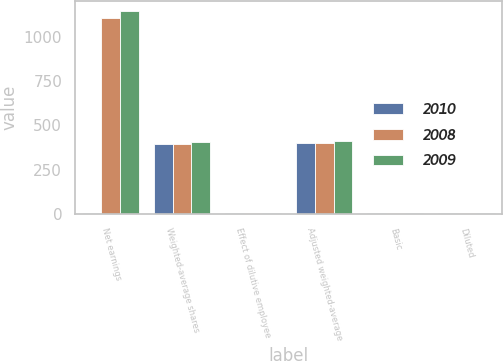<chart> <loc_0><loc_0><loc_500><loc_500><stacked_bar_chart><ecel><fcel>Net earnings<fcel>Weighted-average shares<fcel>Effect of dilutive employee<fcel>Adjusted weighted-average<fcel>Basic<fcel>Diluted<nl><fcel>2010<fcel>5.5<fcel>396.4<fcel>3.1<fcel>399.5<fcel>3.21<fcel>3.19<nl><fcel>2008<fcel>1107.4<fcel>397.4<fcel>2<fcel>399.4<fcel>2.79<fcel>2.77<nl><fcel>2009<fcel>1147.8<fcel>408.1<fcel>5.5<fcel>413.6<fcel>2.81<fcel>2.78<nl></chart> 